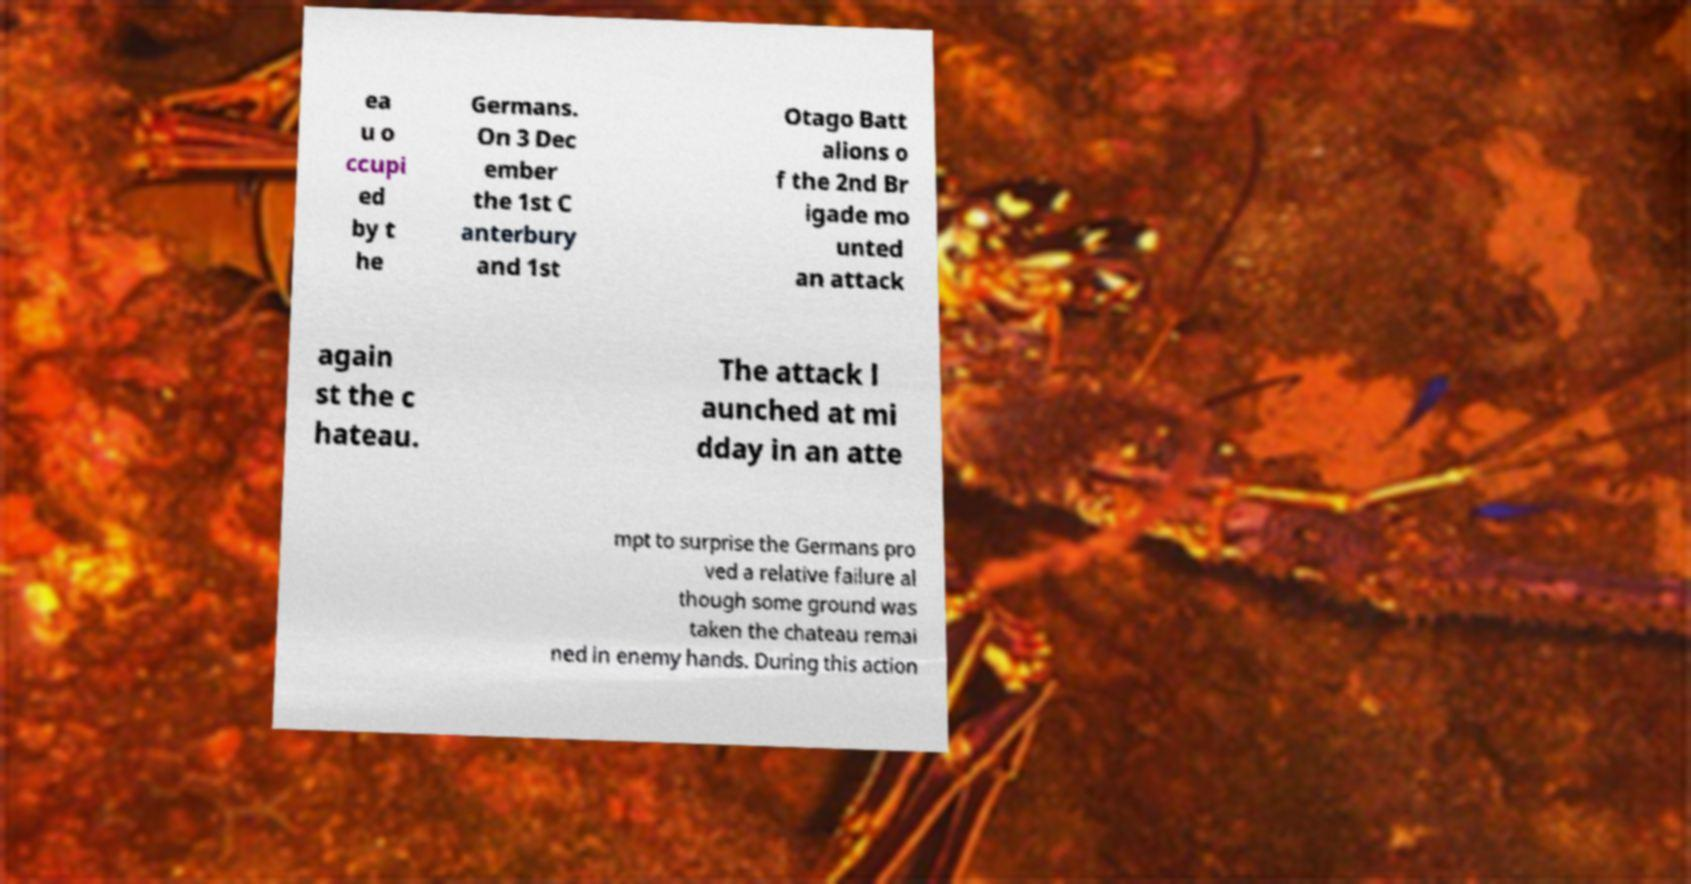For documentation purposes, I need the text within this image transcribed. Could you provide that? ea u o ccupi ed by t he Germans. On 3 Dec ember the 1st C anterbury and 1st Otago Batt alions o f the 2nd Br igade mo unted an attack again st the c hateau. The attack l aunched at mi dday in an atte mpt to surprise the Germans pro ved a relative failure al though some ground was taken the chateau remai ned in enemy hands. During this action 